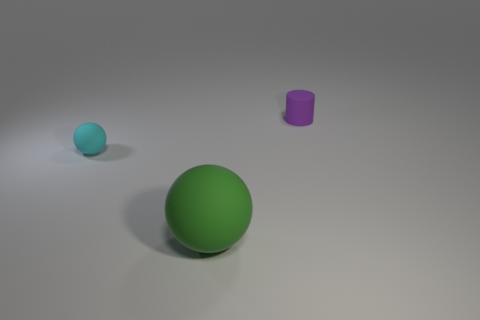Add 2 cyan matte objects. How many objects exist? 5 Subtract all balls. How many objects are left? 1 Add 3 small yellow matte balls. How many small yellow matte balls exist? 3 Subtract 0 yellow cylinders. How many objects are left? 3 Subtract all tiny purple matte things. Subtract all gray shiny balls. How many objects are left? 2 Add 3 tiny purple things. How many tiny purple things are left? 4 